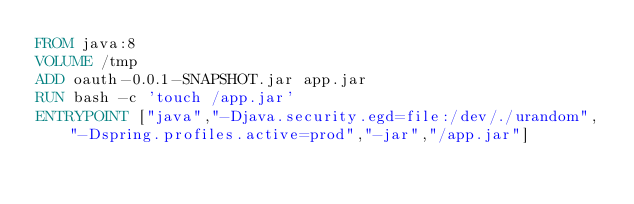Convert code to text. <code><loc_0><loc_0><loc_500><loc_500><_Dockerfile_>FROM java:8
VOLUME /tmp
ADD oauth-0.0.1-SNAPSHOT.jar app.jar
RUN bash -c 'touch /app.jar'
ENTRYPOINT ["java","-Djava.security.egd=file:/dev/./urandom", "-Dspring.profiles.active=prod","-jar","/app.jar"]
</code> 